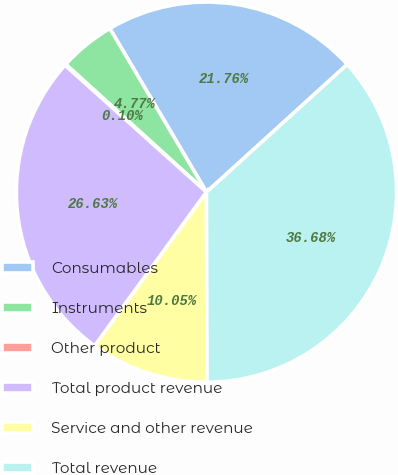Convert chart. <chart><loc_0><loc_0><loc_500><loc_500><pie_chart><fcel>Consumables<fcel>Instruments<fcel>Other product<fcel>Total product revenue<fcel>Service and other revenue<fcel>Total revenue<nl><fcel>21.76%<fcel>4.77%<fcel>0.1%<fcel>26.63%<fcel>10.05%<fcel>36.68%<nl></chart> 